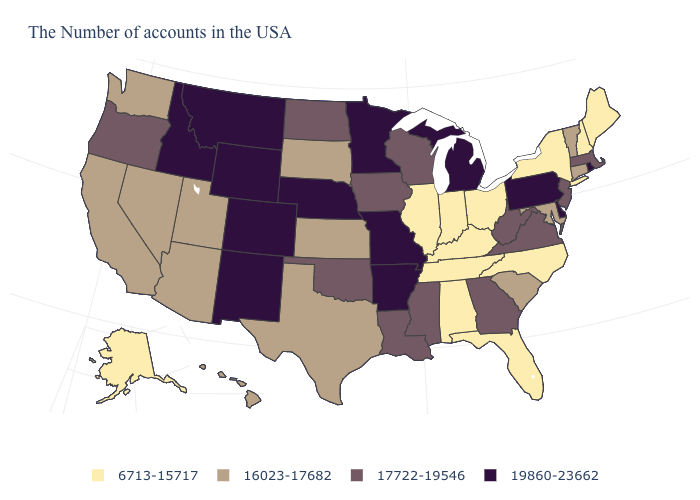Which states hav the highest value in the MidWest?
Keep it brief. Michigan, Missouri, Minnesota, Nebraska. Which states hav the highest value in the West?
Write a very short answer. Wyoming, Colorado, New Mexico, Montana, Idaho. Which states hav the highest value in the Northeast?
Answer briefly. Rhode Island, Pennsylvania. What is the value of Oregon?
Write a very short answer. 17722-19546. Does Florida have the lowest value in the South?
Answer briefly. Yes. How many symbols are there in the legend?
Answer briefly. 4. What is the highest value in states that border Rhode Island?
Keep it brief. 17722-19546. What is the lowest value in states that border Montana?
Answer briefly. 16023-17682. What is the lowest value in the MidWest?
Short answer required. 6713-15717. Does Kentucky have a higher value than New Mexico?
Write a very short answer. No. Name the states that have a value in the range 16023-17682?
Short answer required. Vermont, Connecticut, Maryland, South Carolina, Kansas, Texas, South Dakota, Utah, Arizona, Nevada, California, Washington, Hawaii. What is the lowest value in the West?
Keep it brief. 6713-15717. How many symbols are there in the legend?
Concise answer only. 4. What is the lowest value in states that border South Dakota?
Short answer required. 17722-19546. 